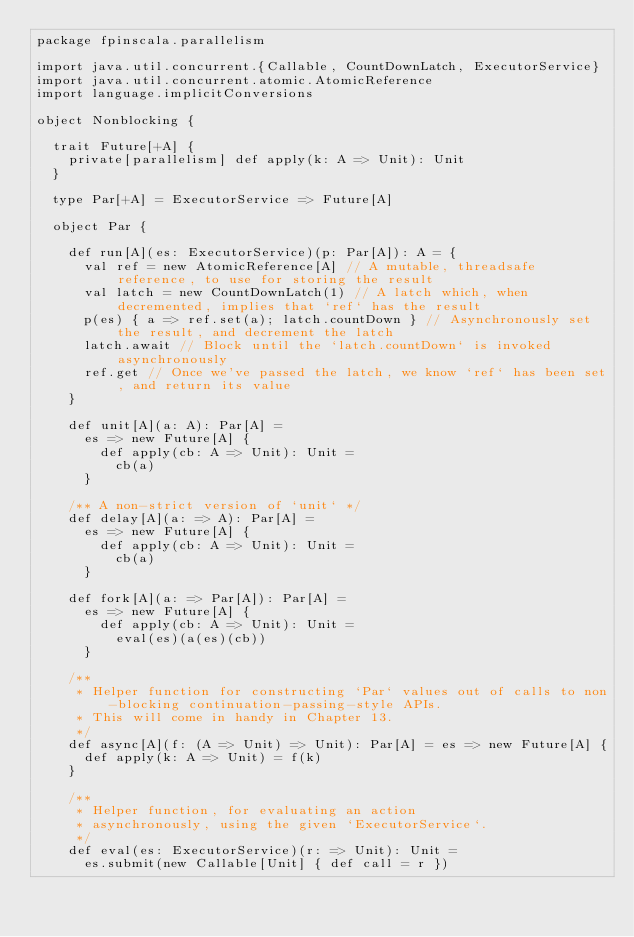<code> <loc_0><loc_0><loc_500><loc_500><_Scala_>package fpinscala.parallelism

import java.util.concurrent.{Callable, CountDownLatch, ExecutorService}
import java.util.concurrent.atomic.AtomicReference
import language.implicitConversions

object Nonblocking {

  trait Future[+A] {
    private[parallelism] def apply(k: A => Unit): Unit
  }

  type Par[+A] = ExecutorService => Future[A]

  object Par {

    def run[A](es: ExecutorService)(p: Par[A]): A = {
      val ref = new AtomicReference[A] // A mutable, threadsafe reference, to use for storing the result
      val latch = new CountDownLatch(1) // A latch which, when decremented, implies that `ref` has the result
      p(es) { a => ref.set(a); latch.countDown } // Asynchronously set the result, and decrement the latch
      latch.await // Block until the `latch.countDown` is invoked asynchronously
      ref.get // Once we've passed the latch, we know `ref` has been set, and return its value
    }

    def unit[A](a: A): Par[A] =
      es => new Future[A] {
        def apply(cb: A => Unit): Unit =
          cb(a)
      }

    /** A non-strict version of `unit` */
    def delay[A](a: => A): Par[A] =
      es => new Future[A] {
        def apply(cb: A => Unit): Unit =
          cb(a)
      }

    def fork[A](a: => Par[A]): Par[A] =
      es => new Future[A] {
        def apply(cb: A => Unit): Unit =
          eval(es)(a(es)(cb))
      }

    /**
     * Helper function for constructing `Par` values out of calls to non-blocking continuation-passing-style APIs.
     * This will come in handy in Chapter 13.
     */
    def async[A](f: (A => Unit) => Unit): Par[A] = es => new Future[A] {
      def apply(k: A => Unit) = f(k)
    }

    /**
     * Helper function, for evaluating an action
     * asynchronously, using the given `ExecutorService`.
     */
    def eval(es: ExecutorService)(r: => Unit): Unit =
      es.submit(new Callable[Unit] { def call = r })
</code> 